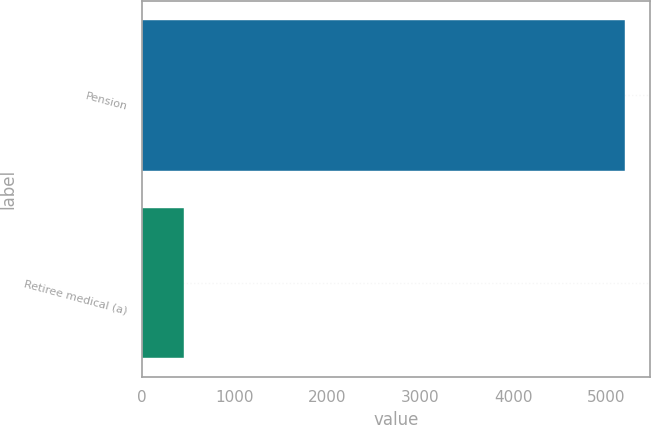Convert chart. <chart><loc_0><loc_0><loc_500><loc_500><bar_chart><fcel>Pension<fcel>Retiree medical (a)<nl><fcel>5210<fcel>455<nl></chart> 